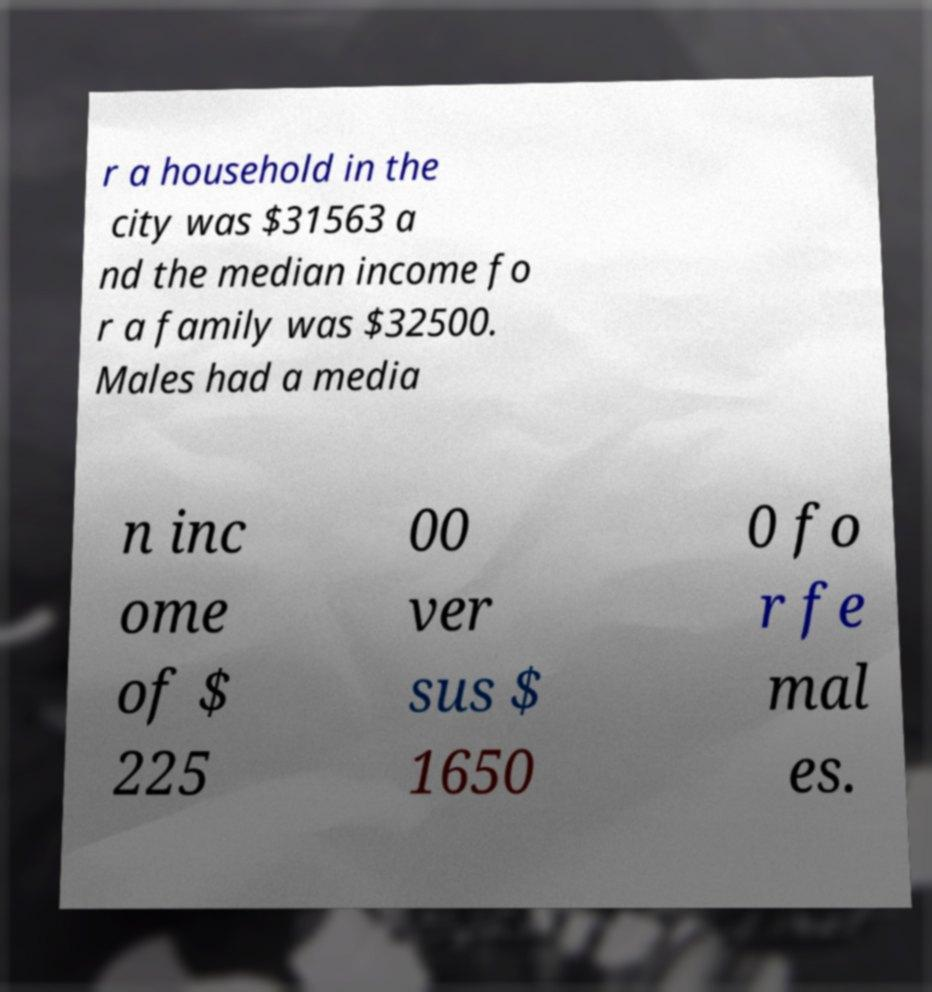Please read and relay the text visible in this image. What does it say? r a household in the city was $31563 a nd the median income fo r a family was $32500. Males had a media n inc ome of $ 225 00 ver sus $ 1650 0 fo r fe mal es. 